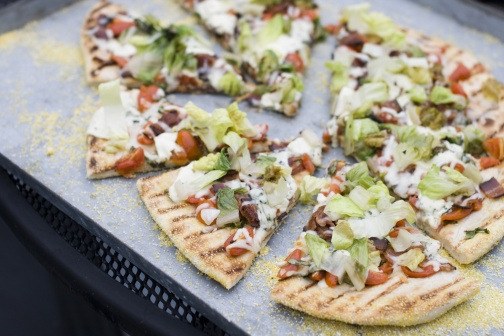What do you notice about the background and setting of the image? The pizza is placed on a black tray that contrasts sharply with the gray, coarse surface underneath. This gray background appears to be a granite or concrete countertop, adding a rugged and simplistic look to the photograph, which emphasizes the colorful and fresh toppings of the pizza even more. The pizza looks so fresh! Can you describe the freshness of the toppings? Absolutely! The toppings on this pizza appear incredibly fresh. The lettuce is crisp and vibrant, a bright green that suggests it's just been chopped. The tomatoes are plump and juicy, adding a touch of red that contrasts beautifully with the green lettuce. The cheese has that perfect melted and slightly browned texture, indicating it was baked to perfection. Each ingredient looks like it's at the peak of its freshness, promising a delightful burst of flavors with every bite. If this pizza scene were a part of a story, what would that story be? In the heart of a bustling Italian kitchen, Marco, a passionate chef renowned for his farm-to-table philosophy, prepares his latest culinary masterpiece. The pizza, now resting invitingly on the tray, is the culmination of a day's work sourcing the freshest ingredients from the local market. As Marco drizzles the final touch of olive oil on the vibrant green lettuce and juicy tomatoes, he reflects on the joy of creating meals that not only tantalize taste buds but also tell a story of tradition and love for fresh, wholesome food. Tonight, this pizza will be the centerpiece of a warm family gathering, where stories are shared, laughter echoed, and memories created. The rugged countertop serves as the silent witness to countless such evenings filled with joy and delicious food. 